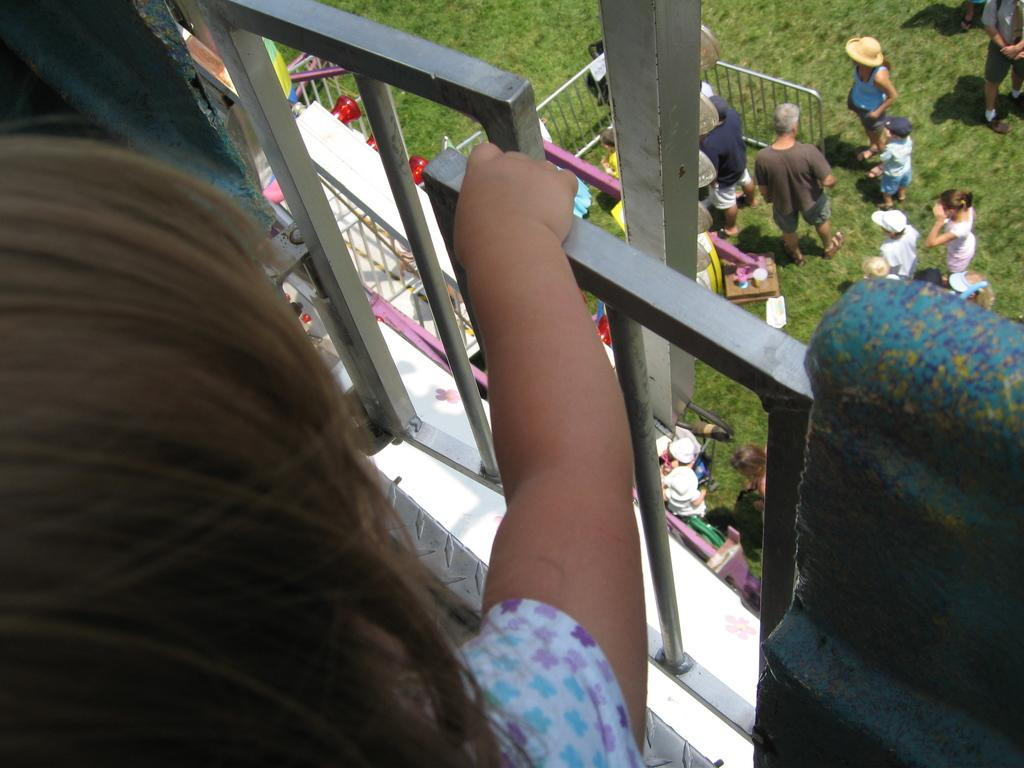What is the main setting of the image? The main setting of the image is a grassy land. Where is the grassy land located in the image? The grassy land is on the right side of the image. Can you describe the people in the image? There is a group of persons standing on the grassy land. What is the kid in the image holding? The kid is holding a metal object. Where is the metal object located in the image? The metal object is on the left side of the image. What type of jam is being spread on the grassy land in the image? There is no jam present in the image; it features a group of persons standing on a grassy land and a kid holding a metal object. 